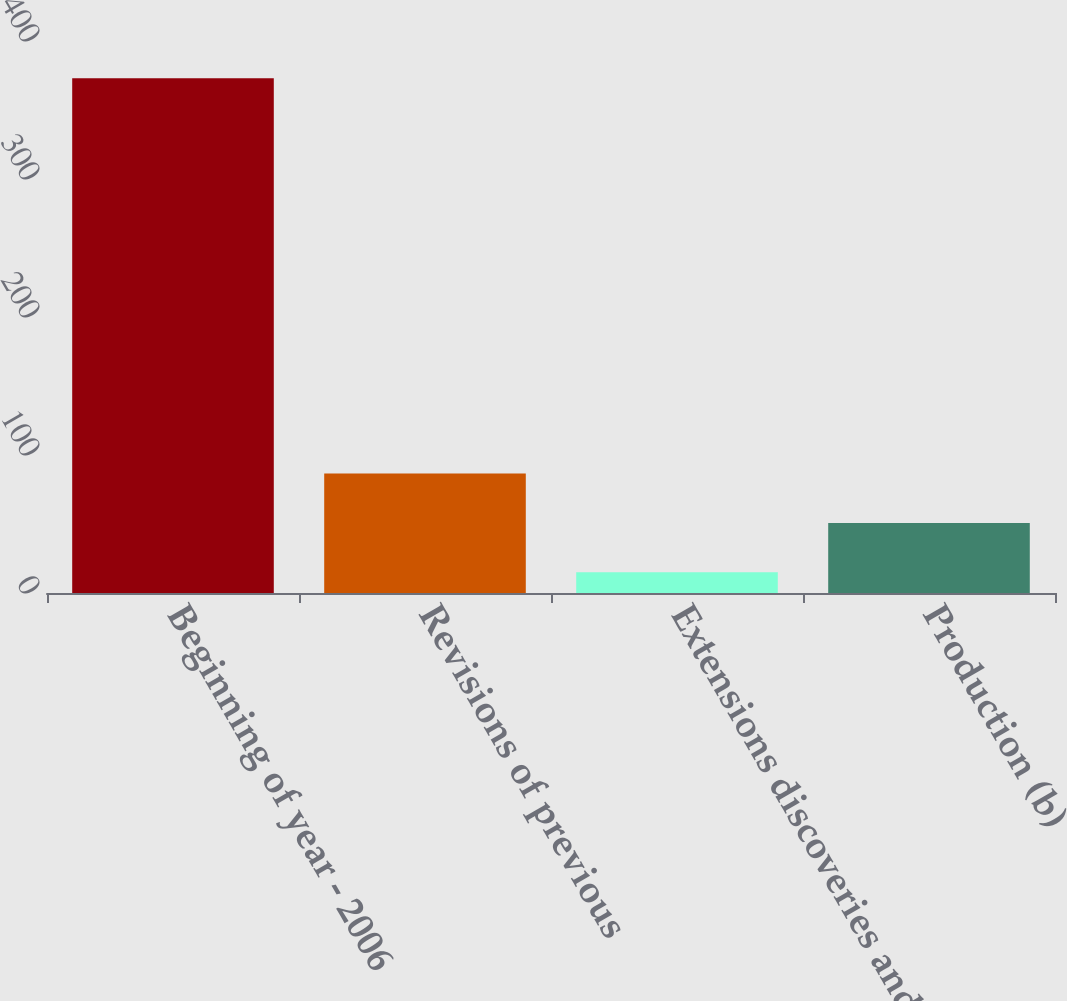Convert chart to OTSL. <chart><loc_0><loc_0><loc_500><loc_500><bar_chart><fcel>Beginning of year - 2006<fcel>Revisions of previous<fcel>Extensions discoveries and<fcel>Production (b)<nl><fcel>373<fcel>86.6<fcel>15<fcel>50.8<nl></chart> 